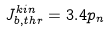Convert formula to latex. <formula><loc_0><loc_0><loc_500><loc_500>J _ { b , t h r } ^ { k i n } = 3 . 4 p _ { n }</formula> 